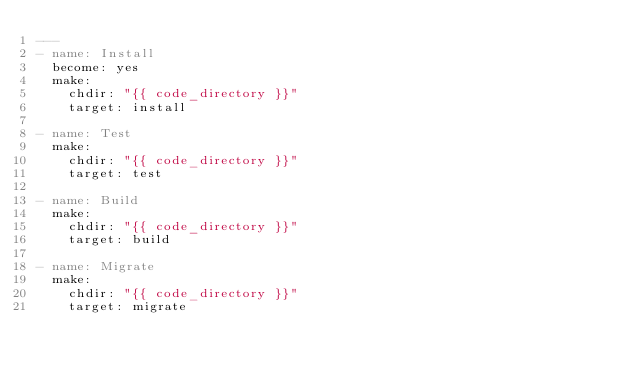<code> <loc_0><loc_0><loc_500><loc_500><_YAML_>---
- name: Install
  become: yes
  make:
    chdir: "{{ code_directory }}"
    target: install

- name: Test
  make:
    chdir: "{{ code_directory }}"
    target: test

- name: Build
  make:
    chdir: "{{ code_directory }}"
    target: build

- name: Migrate
  make:
    chdir: "{{ code_directory }}"
    target: migrate
</code> 